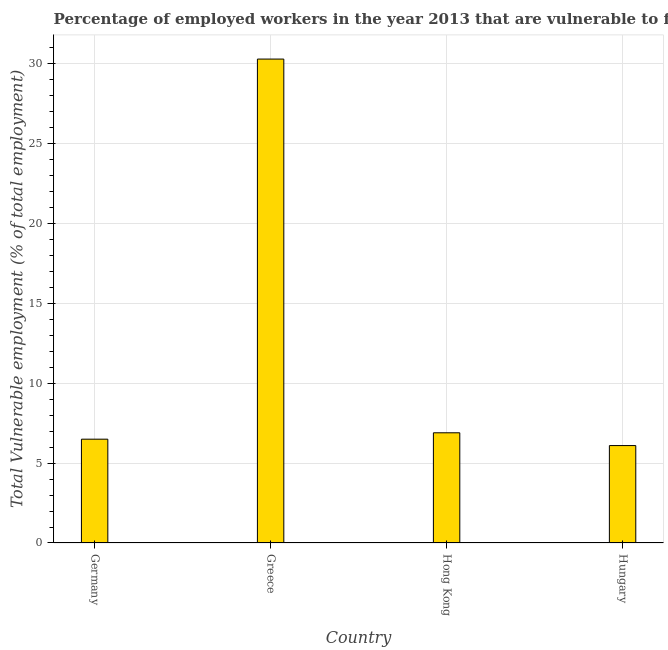Does the graph contain any zero values?
Offer a very short reply. No. Does the graph contain grids?
Make the answer very short. Yes. What is the title of the graph?
Give a very brief answer. Percentage of employed workers in the year 2013 that are vulnerable to fall into poverty. What is the label or title of the Y-axis?
Ensure brevity in your answer.  Total Vulnerable employment (% of total employment). What is the total vulnerable employment in Hungary?
Ensure brevity in your answer.  6.1. Across all countries, what is the maximum total vulnerable employment?
Your response must be concise. 30.3. Across all countries, what is the minimum total vulnerable employment?
Provide a succinct answer. 6.1. In which country was the total vulnerable employment maximum?
Provide a succinct answer. Greece. In which country was the total vulnerable employment minimum?
Make the answer very short. Hungary. What is the sum of the total vulnerable employment?
Provide a succinct answer. 49.8. What is the difference between the total vulnerable employment in Greece and Hong Kong?
Your response must be concise. 23.4. What is the average total vulnerable employment per country?
Keep it short and to the point. 12.45. What is the median total vulnerable employment?
Your answer should be very brief. 6.7. What is the ratio of the total vulnerable employment in Germany to that in Hong Kong?
Offer a terse response. 0.94. Is the total vulnerable employment in Germany less than that in Hungary?
Offer a very short reply. No. Is the difference between the total vulnerable employment in Greece and Hong Kong greater than the difference between any two countries?
Your answer should be compact. No. What is the difference between the highest and the second highest total vulnerable employment?
Your answer should be very brief. 23.4. What is the difference between the highest and the lowest total vulnerable employment?
Give a very brief answer. 24.2. In how many countries, is the total vulnerable employment greater than the average total vulnerable employment taken over all countries?
Give a very brief answer. 1. How many bars are there?
Your answer should be compact. 4. How many countries are there in the graph?
Your answer should be very brief. 4. What is the difference between two consecutive major ticks on the Y-axis?
Keep it short and to the point. 5. What is the Total Vulnerable employment (% of total employment) of Greece?
Give a very brief answer. 30.3. What is the Total Vulnerable employment (% of total employment) of Hong Kong?
Make the answer very short. 6.9. What is the Total Vulnerable employment (% of total employment) of Hungary?
Make the answer very short. 6.1. What is the difference between the Total Vulnerable employment (% of total employment) in Germany and Greece?
Make the answer very short. -23.8. What is the difference between the Total Vulnerable employment (% of total employment) in Germany and Hong Kong?
Your answer should be compact. -0.4. What is the difference between the Total Vulnerable employment (% of total employment) in Germany and Hungary?
Provide a succinct answer. 0.4. What is the difference between the Total Vulnerable employment (% of total employment) in Greece and Hong Kong?
Offer a very short reply. 23.4. What is the difference between the Total Vulnerable employment (% of total employment) in Greece and Hungary?
Ensure brevity in your answer.  24.2. What is the difference between the Total Vulnerable employment (% of total employment) in Hong Kong and Hungary?
Ensure brevity in your answer.  0.8. What is the ratio of the Total Vulnerable employment (% of total employment) in Germany to that in Greece?
Provide a succinct answer. 0.21. What is the ratio of the Total Vulnerable employment (% of total employment) in Germany to that in Hong Kong?
Provide a succinct answer. 0.94. What is the ratio of the Total Vulnerable employment (% of total employment) in Germany to that in Hungary?
Your answer should be very brief. 1.07. What is the ratio of the Total Vulnerable employment (% of total employment) in Greece to that in Hong Kong?
Ensure brevity in your answer.  4.39. What is the ratio of the Total Vulnerable employment (% of total employment) in Greece to that in Hungary?
Offer a very short reply. 4.97. What is the ratio of the Total Vulnerable employment (% of total employment) in Hong Kong to that in Hungary?
Your response must be concise. 1.13. 